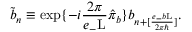Convert formula to latex. <formula><loc_0><loc_0><loc_500><loc_500>\tilde { b } _ { n } \equiv \exp \{ - i \frac { 2 \pi } { e _ { - } L } \hat { \pi } _ { b } \} b _ { n + [ \frac { e _ { - } b L } { 2 { \pi } { } } ] } .</formula> 